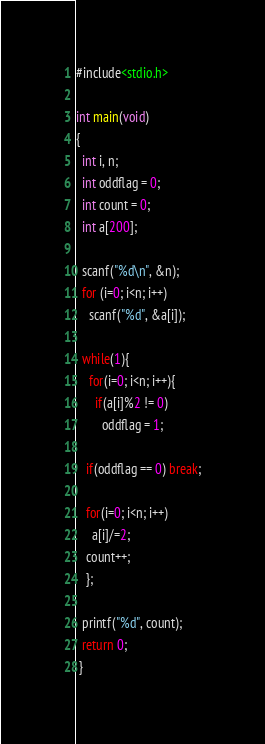<code> <loc_0><loc_0><loc_500><loc_500><_C_>#include<stdio.h>
 
int main(void)
{
  int i, n;
  int oddflag = 0;
  int count = 0;
  int a[200];
  
  scanf("%d\n", &n);
  for (i=0; i<n; i++)
    scanf("%d", &a[i]);
  
  while(1){
    for(i=0; i<n; i++){
      if(a[i]%2 != 0)
        oddflag = 1;
      
   if(oddflag == 0) break;
    
   for(i=0; i<n; i++)
     a[i]/=2;
   count++;
   };
    
  printf("%d", count);
  return 0;
 }</code> 